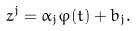<formula> <loc_0><loc_0><loc_500><loc_500>z ^ { j } = \alpha _ { j } \varphi ( t ) + b _ { j } .</formula> 